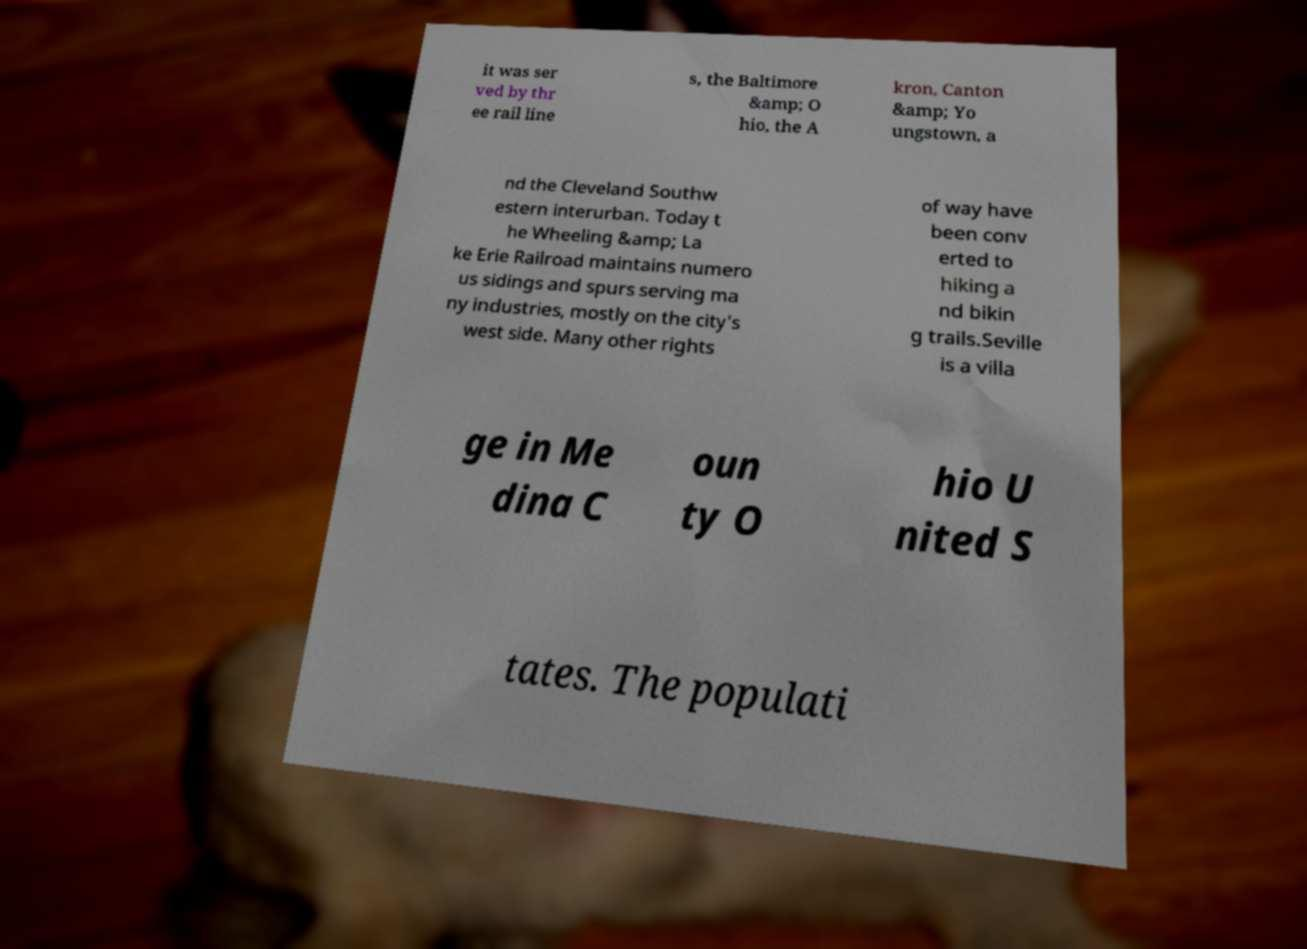Please identify and transcribe the text found in this image. it was ser ved by thr ee rail line s, the Baltimore &amp; O hio, the A kron, Canton &amp; Yo ungstown, a nd the Cleveland Southw estern interurban. Today t he Wheeling &amp; La ke Erie Railroad maintains numero us sidings and spurs serving ma ny industries, mostly on the city's west side. Many other rights of way have been conv erted to hiking a nd bikin g trails.Seville is a villa ge in Me dina C oun ty O hio U nited S tates. The populati 